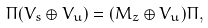Convert formula to latex. <formula><loc_0><loc_0><loc_500><loc_500>\Pi ( V _ { s } \oplus V _ { u } ) = ( M _ { z } \oplus V _ { u } ) \Pi ,</formula> 